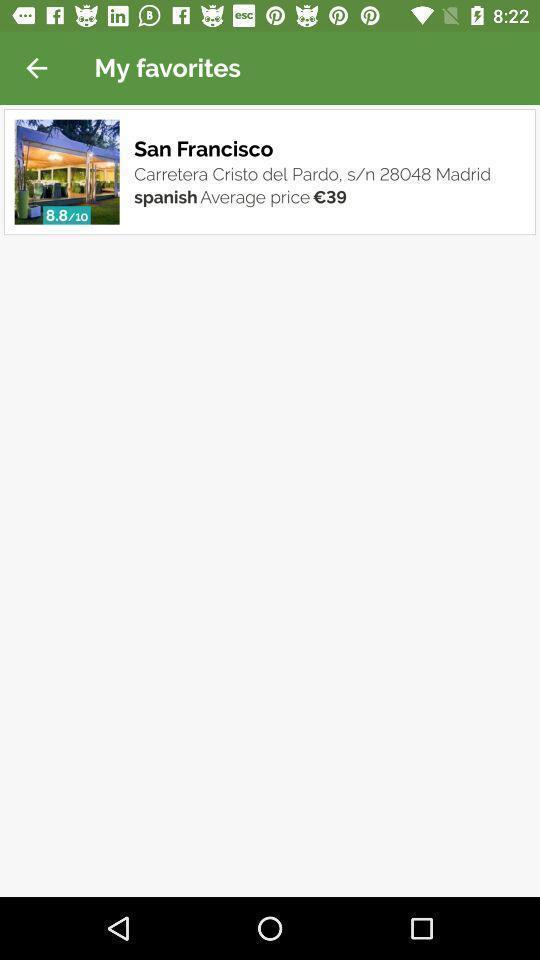Summarize the information in this screenshot. Screen displaying the favorite location. 